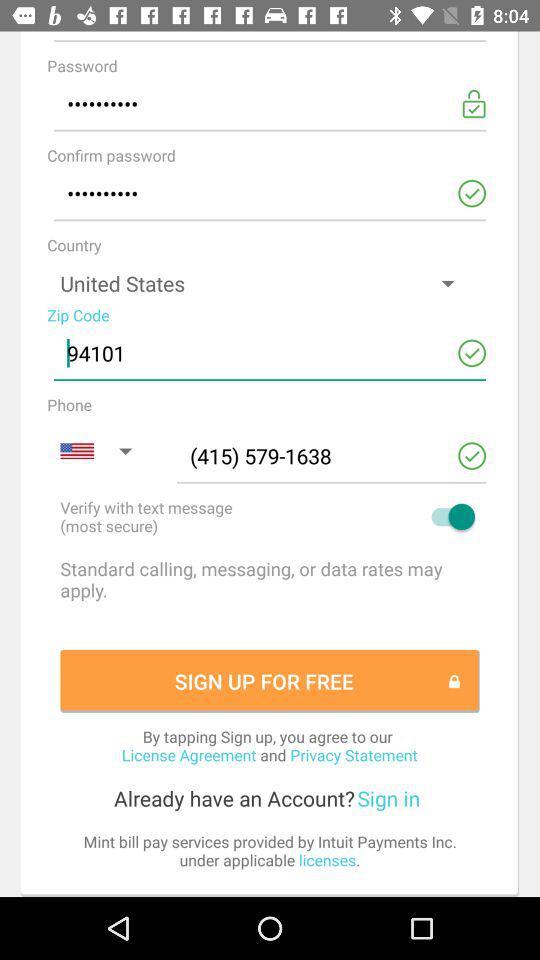What is the selected country? The selected country is the United States. 